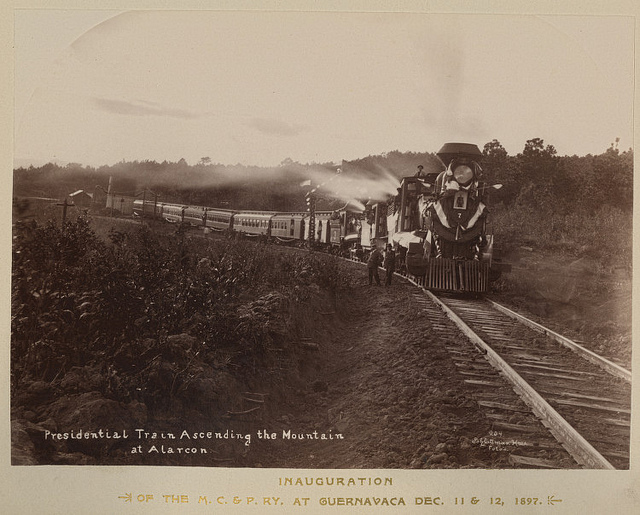Read all the text in this image. Presidential Train Ascending Mountain Alarcon 1897 12 & 11 DEC. GUERNAVACA AT INAUGURATION RY THE OF the 